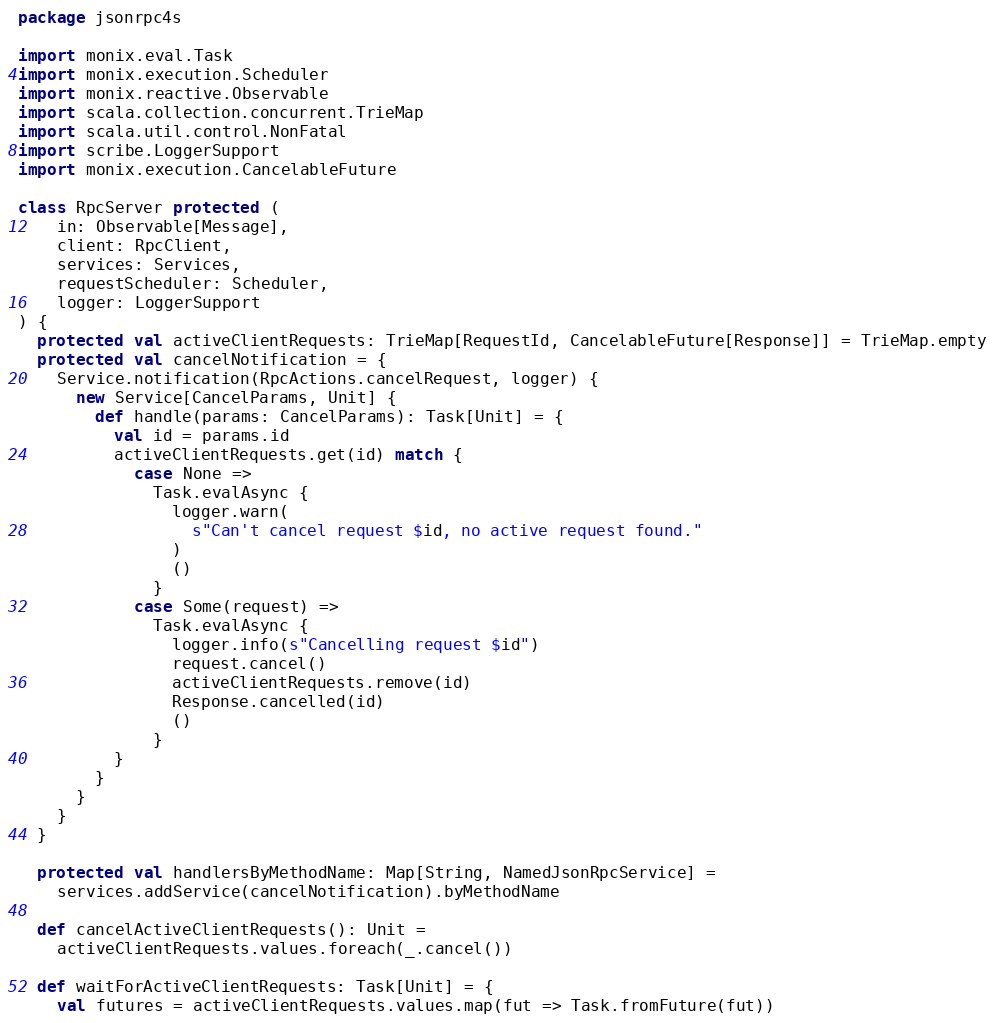<code> <loc_0><loc_0><loc_500><loc_500><_Scala_>package jsonrpc4s

import monix.eval.Task
import monix.execution.Scheduler
import monix.reactive.Observable
import scala.collection.concurrent.TrieMap
import scala.util.control.NonFatal
import scribe.LoggerSupport
import monix.execution.CancelableFuture

class RpcServer protected (
    in: Observable[Message],
    client: RpcClient,
    services: Services,
    requestScheduler: Scheduler,
    logger: LoggerSupport
) {
  protected val activeClientRequests: TrieMap[RequestId, CancelableFuture[Response]] = TrieMap.empty
  protected val cancelNotification = {
    Service.notification(RpcActions.cancelRequest, logger) {
      new Service[CancelParams, Unit] {
        def handle(params: CancelParams): Task[Unit] = {
          val id = params.id
          activeClientRequests.get(id) match {
            case None =>
              Task.evalAsync {
                logger.warn(
                  s"Can't cancel request $id, no active request found."
                )
                ()
              }
            case Some(request) =>
              Task.evalAsync {
                logger.info(s"Cancelling request $id")
                request.cancel()
                activeClientRequests.remove(id)
                Response.cancelled(id)
                ()
              }
          }
        }
      }
    }
  }

  protected val handlersByMethodName: Map[String, NamedJsonRpcService] =
    services.addService(cancelNotification).byMethodName

  def cancelActiveClientRequests(): Unit =
    activeClientRequests.values.foreach(_.cancel())

  def waitForActiveClientRequests: Task[Unit] = {
    val futures = activeClientRequests.values.map(fut => Task.fromFuture(fut))</code> 